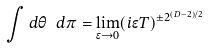Convert formula to latex. <formula><loc_0><loc_0><loc_500><loc_500>\int d \theta \ d \pi = \lim _ { \epsilon \rightarrow 0 } ( i \epsilon T ) ^ { \pm 2 ^ { ( D - 2 ) / 2 } }</formula> 